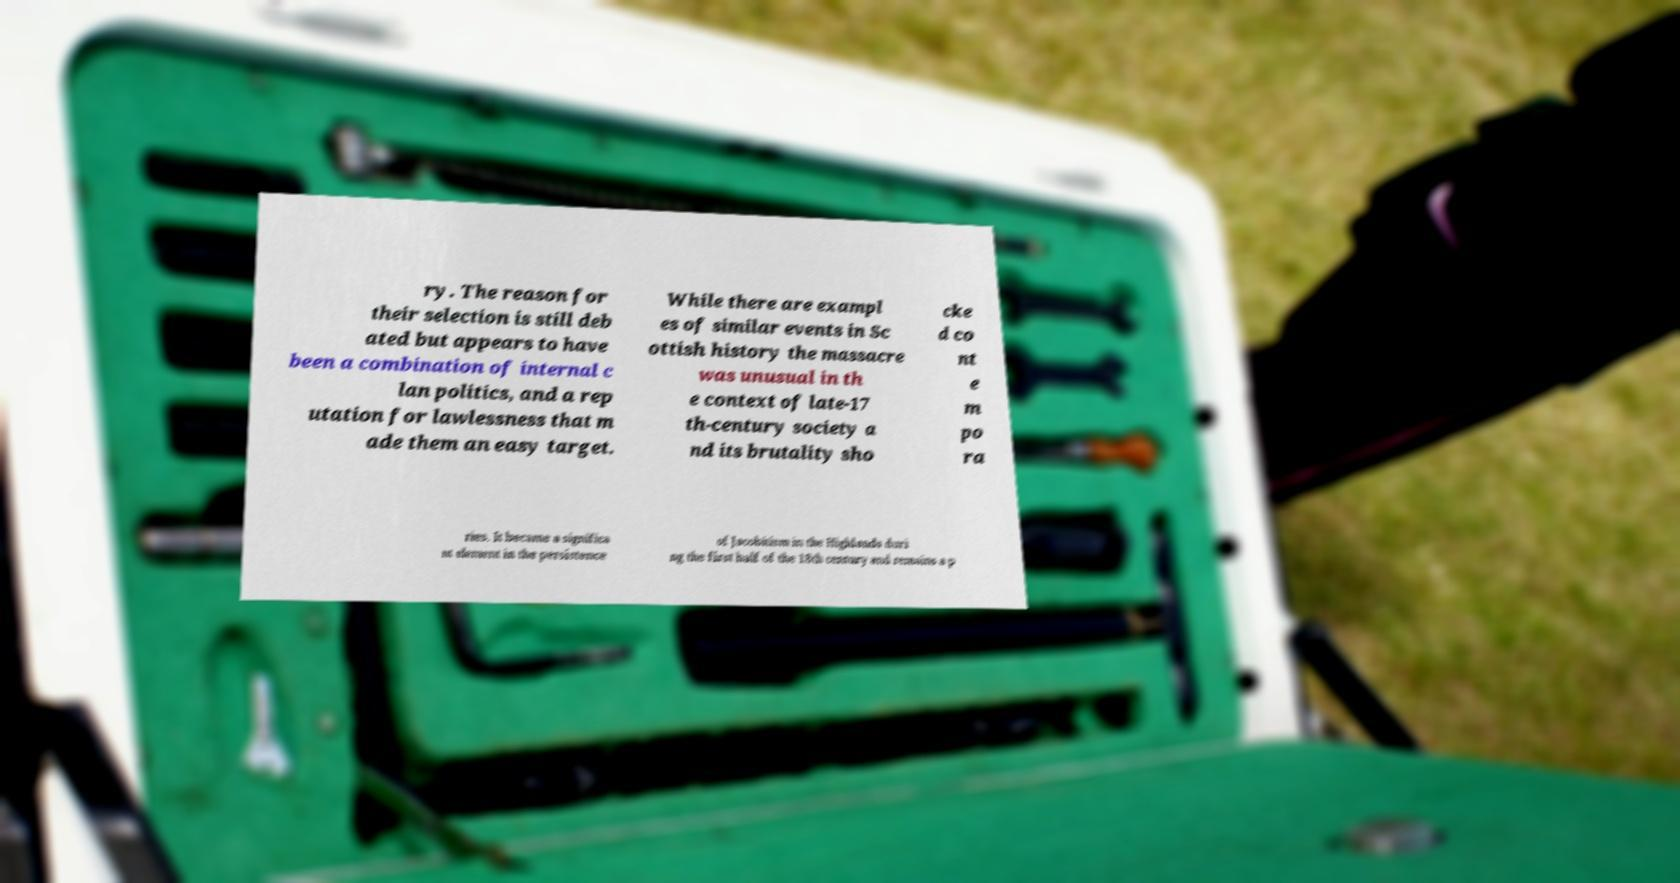What messages or text are displayed in this image? I need them in a readable, typed format. ry. The reason for their selection is still deb ated but appears to have been a combination of internal c lan politics, and a rep utation for lawlessness that m ade them an easy target. While there are exampl es of similar events in Sc ottish history the massacre was unusual in th e context of late-17 th-century society a nd its brutality sho cke d co nt e m po ra ries. It became a significa nt element in the persistence of Jacobitism in the Highlands duri ng the first half of the 18th century and remains a p 